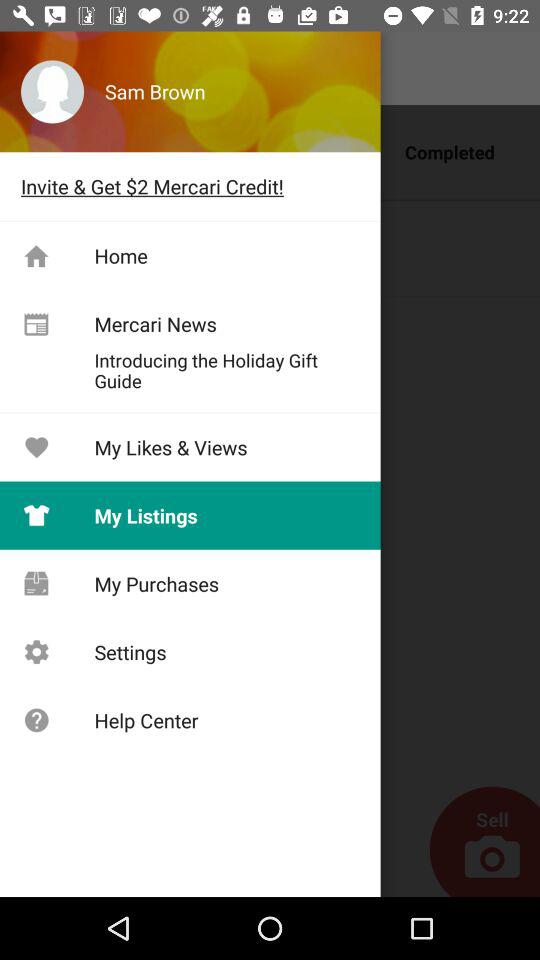How much Mercari Credit can be earned? The Mercari Credit that can be earned is $2. 